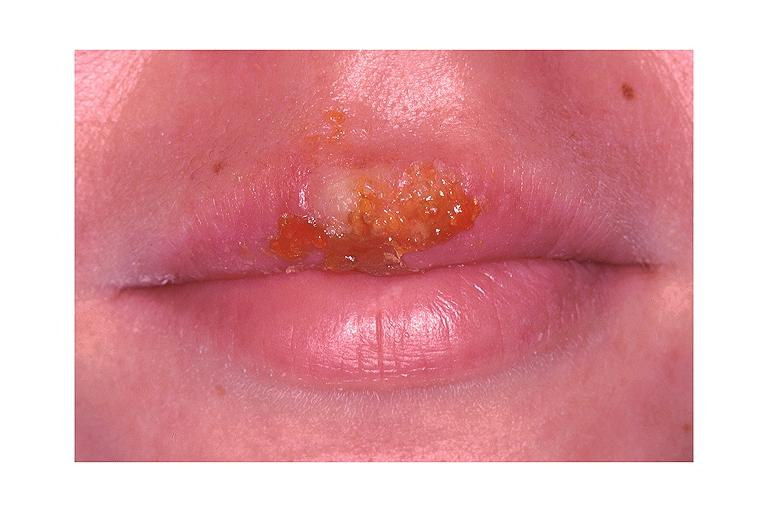s mesothelioma present?
Answer the question using a single word or phrase. No 